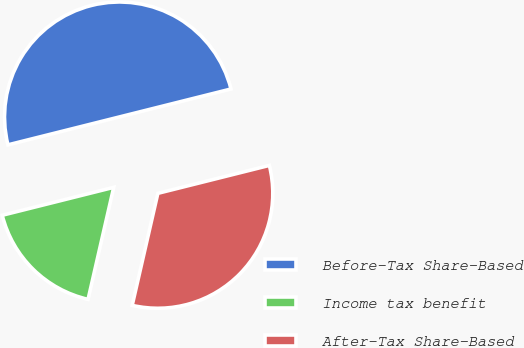Convert chart. <chart><loc_0><loc_0><loc_500><loc_500><pie_chart><fcel>Before-Tax Share-Based<fcel>Income tax benefit<fcel>After-Tax Share-Based<nl><fcel>50.0%<fcel>17.51%<fcel>32.49%<nl></chart> 